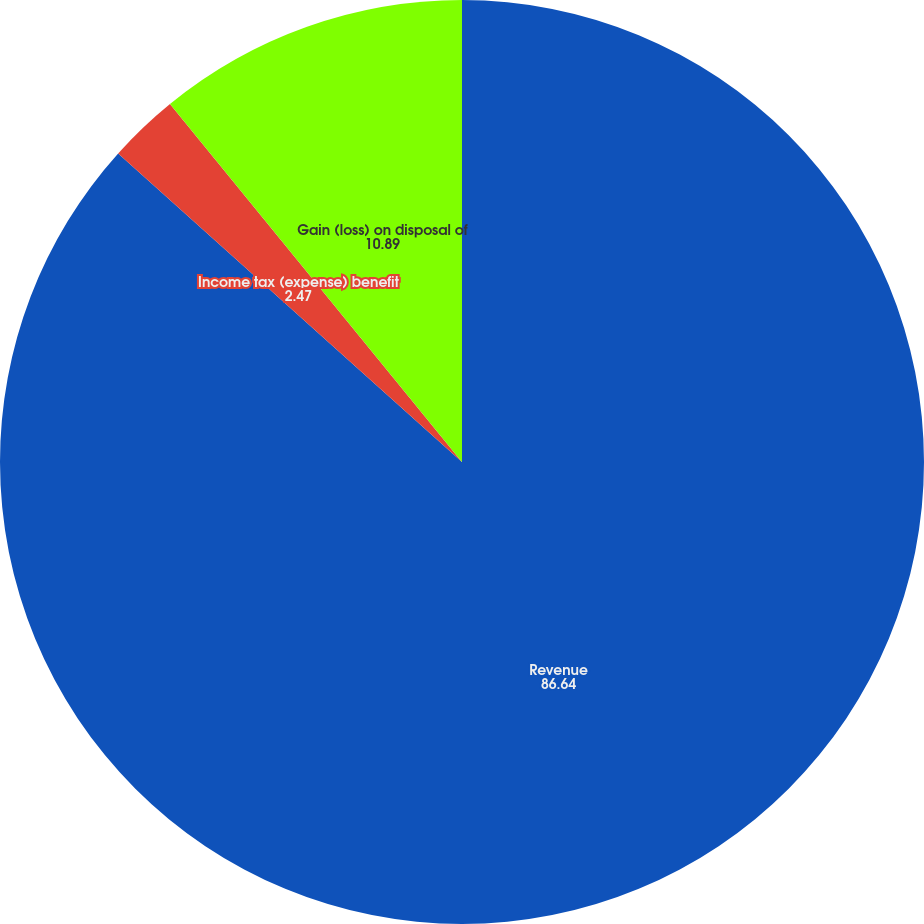Convert chart to OTSL. <chart><loc_0><loc_0><loc_500><loc_500><pie_chart><fcel>Revenue<fcel>Income tax (expense) benefit<fcel>Gain (loss) on disposal of<nl><fcel>86.64%<fcel>2.47%<fcel>10.89%<nl></chart> 